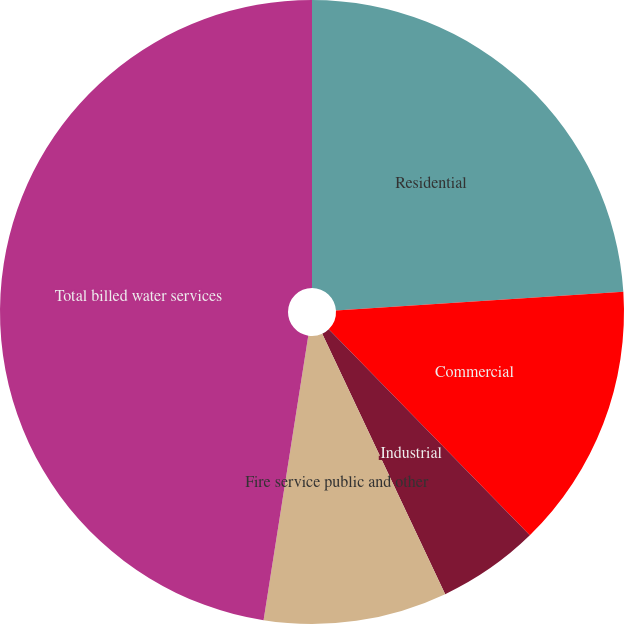Convert chart to OTSL. <chart><loc_0><loc_0><loc_500><loc_500><pie_chart><fcel>Residential<fcel>Commercial<fcel>Industrial<fcel>Fire service public and other<fcel>Total billed water services<nl><fcel>23.97%<fcel>13.73%<fcel>5.28%<fcel>9.5%<fcel>47.52%<nl></chart> 